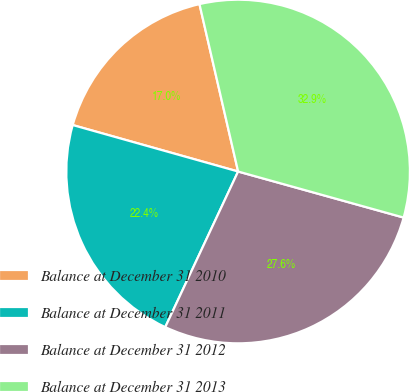<chart> <loc_0><loc_0><loc_500><loc_500><pie_chart><fcel>Balance at December 31 2010<fcel>Balance at December 31 2011<fcel>Balance at December 31 2012<fcel>Balance at December 31 2013<nl><fcel>17.03%<fcel>22.39%<fcel>27.65%<fcel>32.93%<nl></chart> 